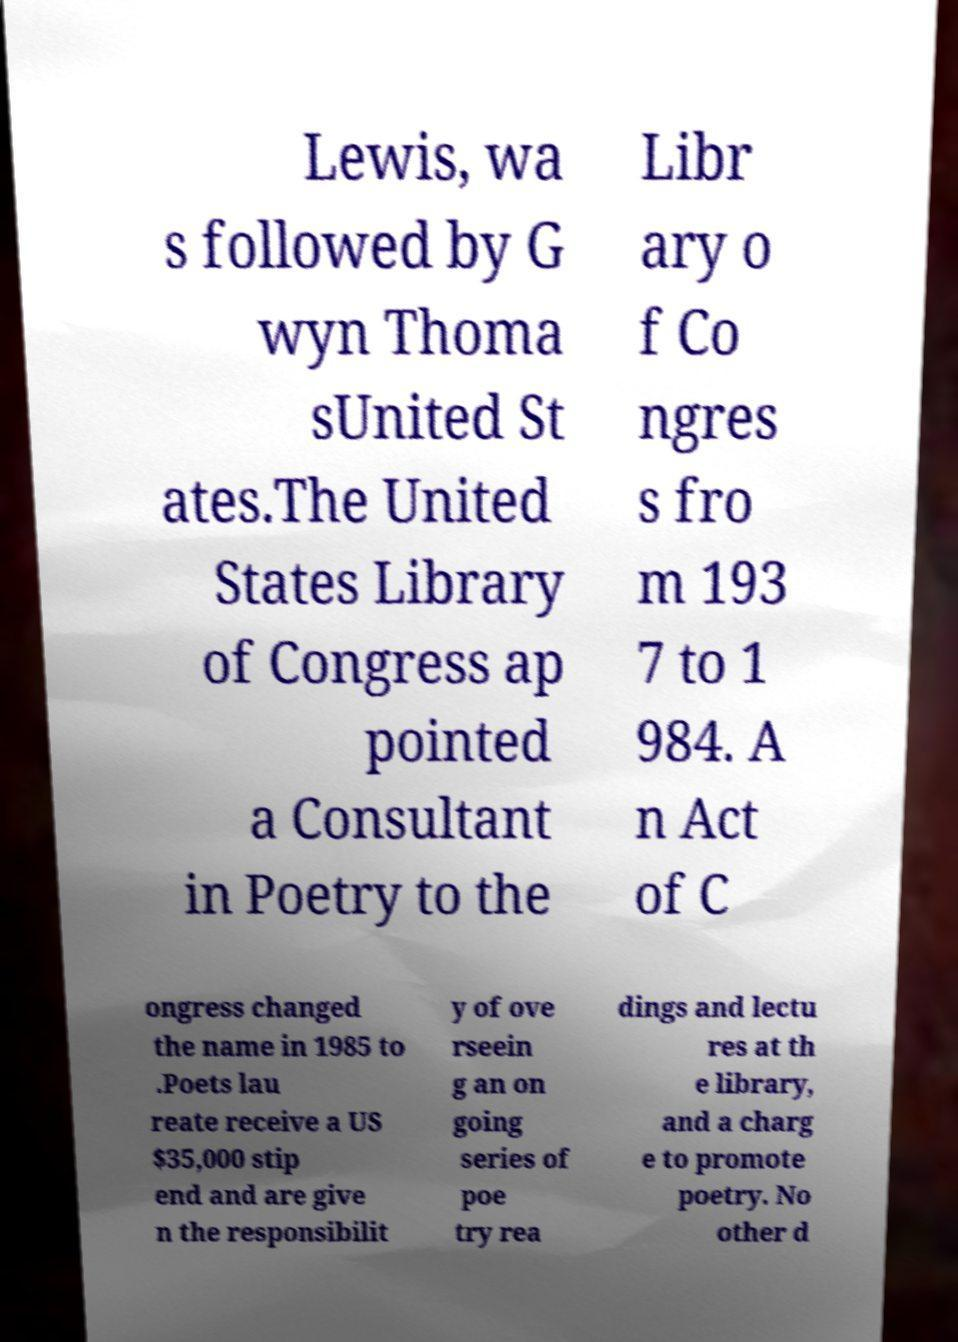For documentation purposes, I need the text within this image transcribed. Could you provide that? Lewis, wa s followed by G wyn Thoma sUnited St ates.The United States Library of Congress ap pointed a Consultant in Poetry to the Libr ary o f Co ngres s fro m 193 7 to 1 984. A n Act of C ongress changed the name in 1985 to .Poets lau reate receive a US $35,000 stip end and are give n the responsibilit y of ove rseein g an on going series of poe try rea dings and lectu res at th e library, and a charg e to promote poetry. No other d 